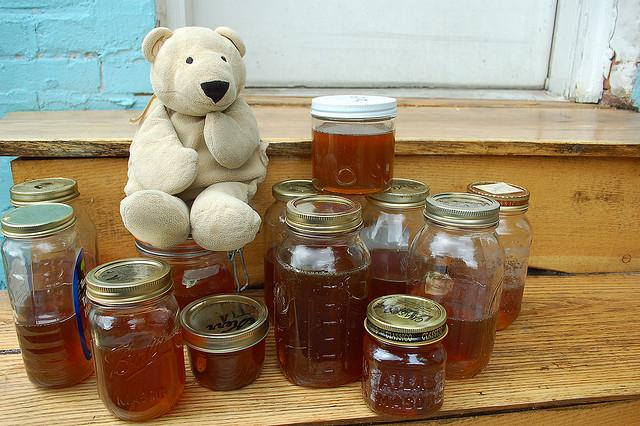What kind of animal is the plush toy?
Keep it brief. Bear. Could this honey be for sale?
Write a very short answer. Yes. What is the jars filled with?
Quick response, please. Honey. 